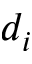<formula> <loc_0><loc_0><loc_500><loc_500>d _ { i }</formula> 